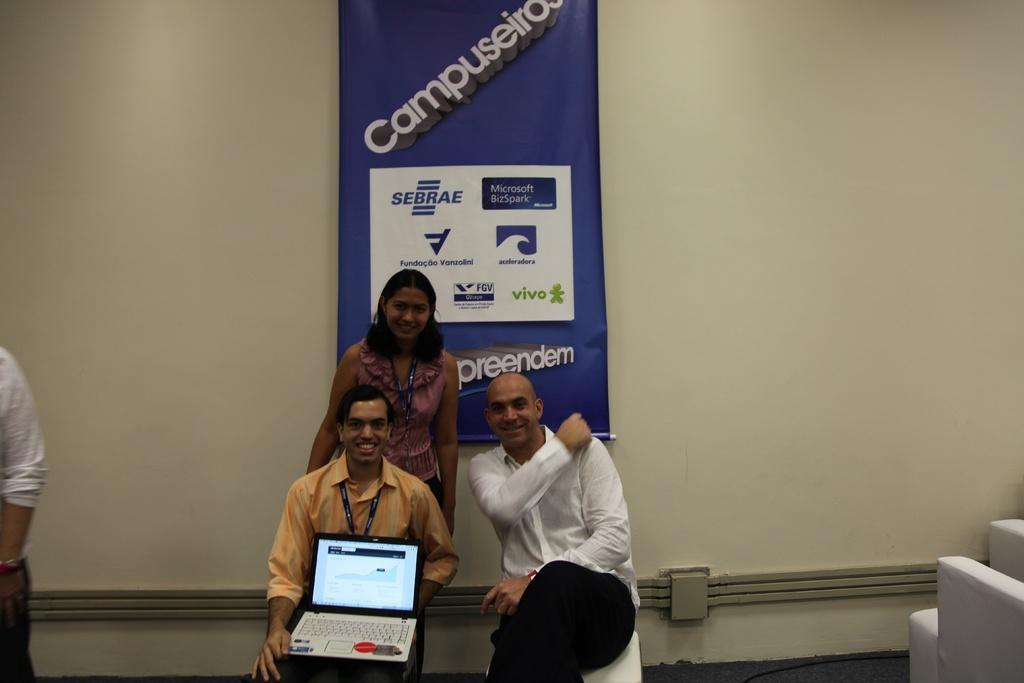Could you give a brief overview of what you see in this image? In the picture I can see two men sitting on the chairs and they are smiling. There is a man on the left side is holding the laptop in his hand. In the background, I can see a woman standing on the floor and she is smiling. There is a banner on the wall. I can see a person on the left side, though his face is not visible. 